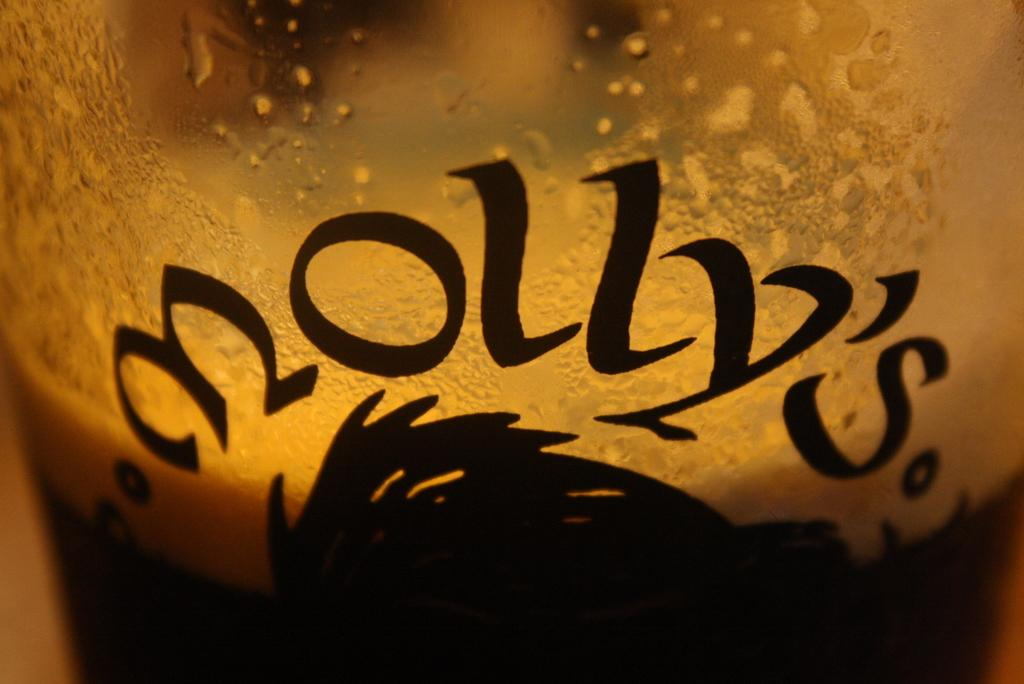Provide a one-sentence caption for the provided image. a close up of a Molly's bar glass half full of ale. 